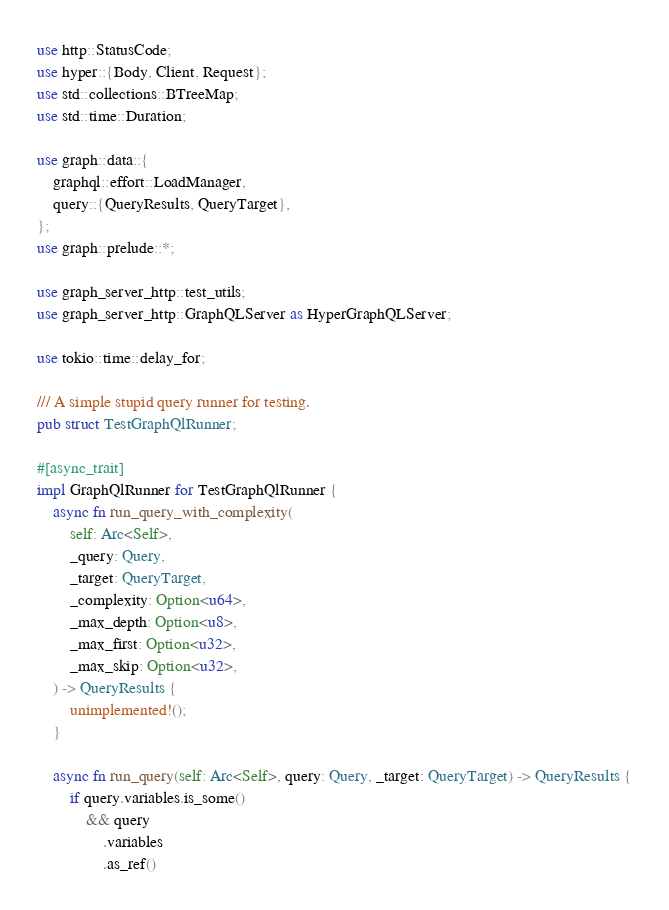Convert code to text. <code><loc_0><loc_0><loc_500><loc_500><_Rust_>use http::StatusCode;
use hyper::{Body, Client, Request};
use std::collections::BTreeMap;
use std::time::Duration;

use graph::data::{
    graphql::effort::LoadManager,
    query::{QueryResults, QueryTarget},
};
use graph::prelude::*;

use graph_server_http::test_utils;
use graph_server_http::GraphQLServer as HyperGraphQLServer;

use tokio::time::delay_for;

/// A simple stupid query runner for testing.
pub struct TestGraphQlRunner;

#[async_trait]
impl GraphQlRunner for TestGraphQlRunner {
    async fn run_query_with_complexity(
        self: Arc<Self>,
        _query: Query,
        _target: QueryTarget,
        _complexity: Option<u64>,
        _max_depth: Option<u8>,
        _max_first: Option<u32>,
        _max_skip: Option<u32>,
    ) -> QueryResults {
        unimplemented!();
    }

    async fn run_query(self: Arc<Self>, query: Query, _target: QueryTarget) -> QueryResults {
        if query.variables.is_some()
            && query
                .variables
                .as_ref()</code> 